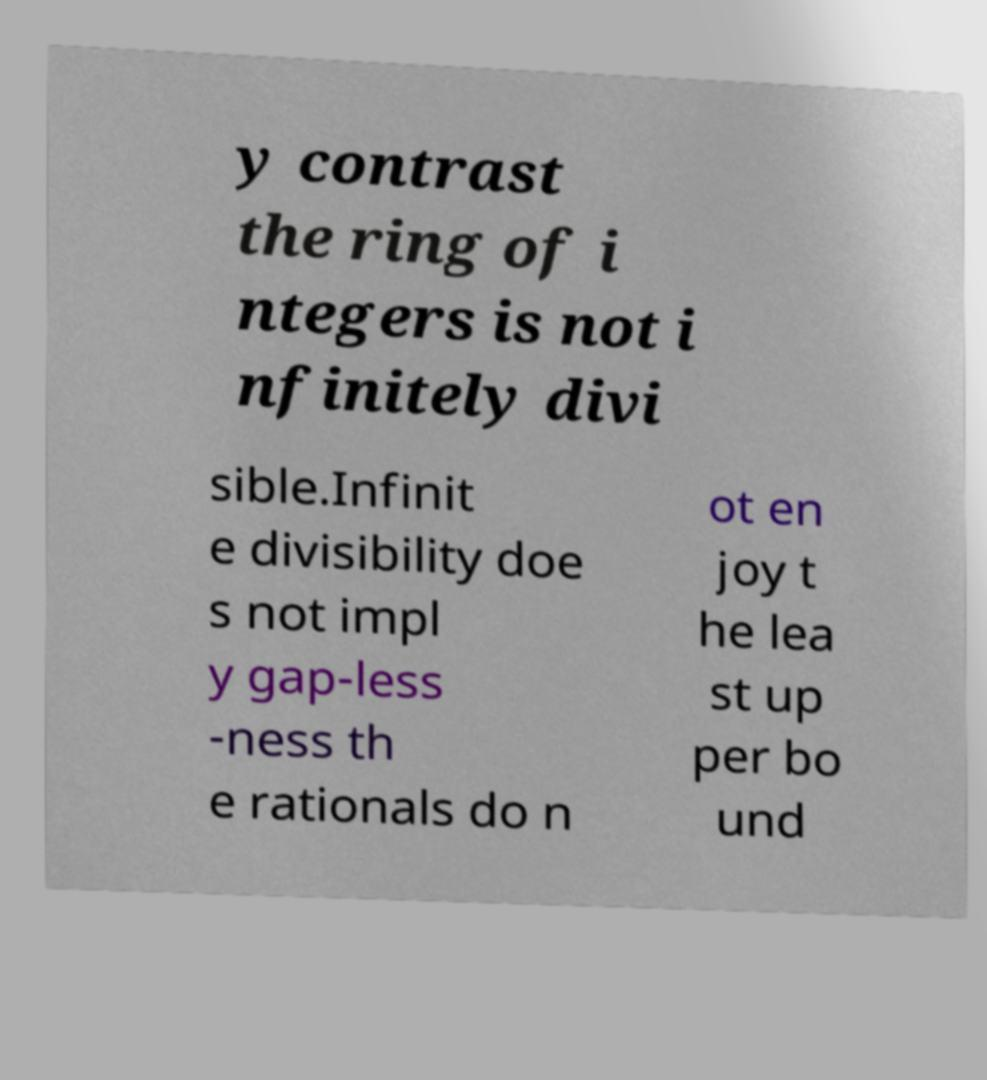Please read and relay the text visible in this image. What does it say? y contrast the ring of i ntegers is not i nfinitely divi sible.Infinit e divisibility doe s not impl y gap-less -ness th e rationals do n ot en joy t he lea st up per bo und 